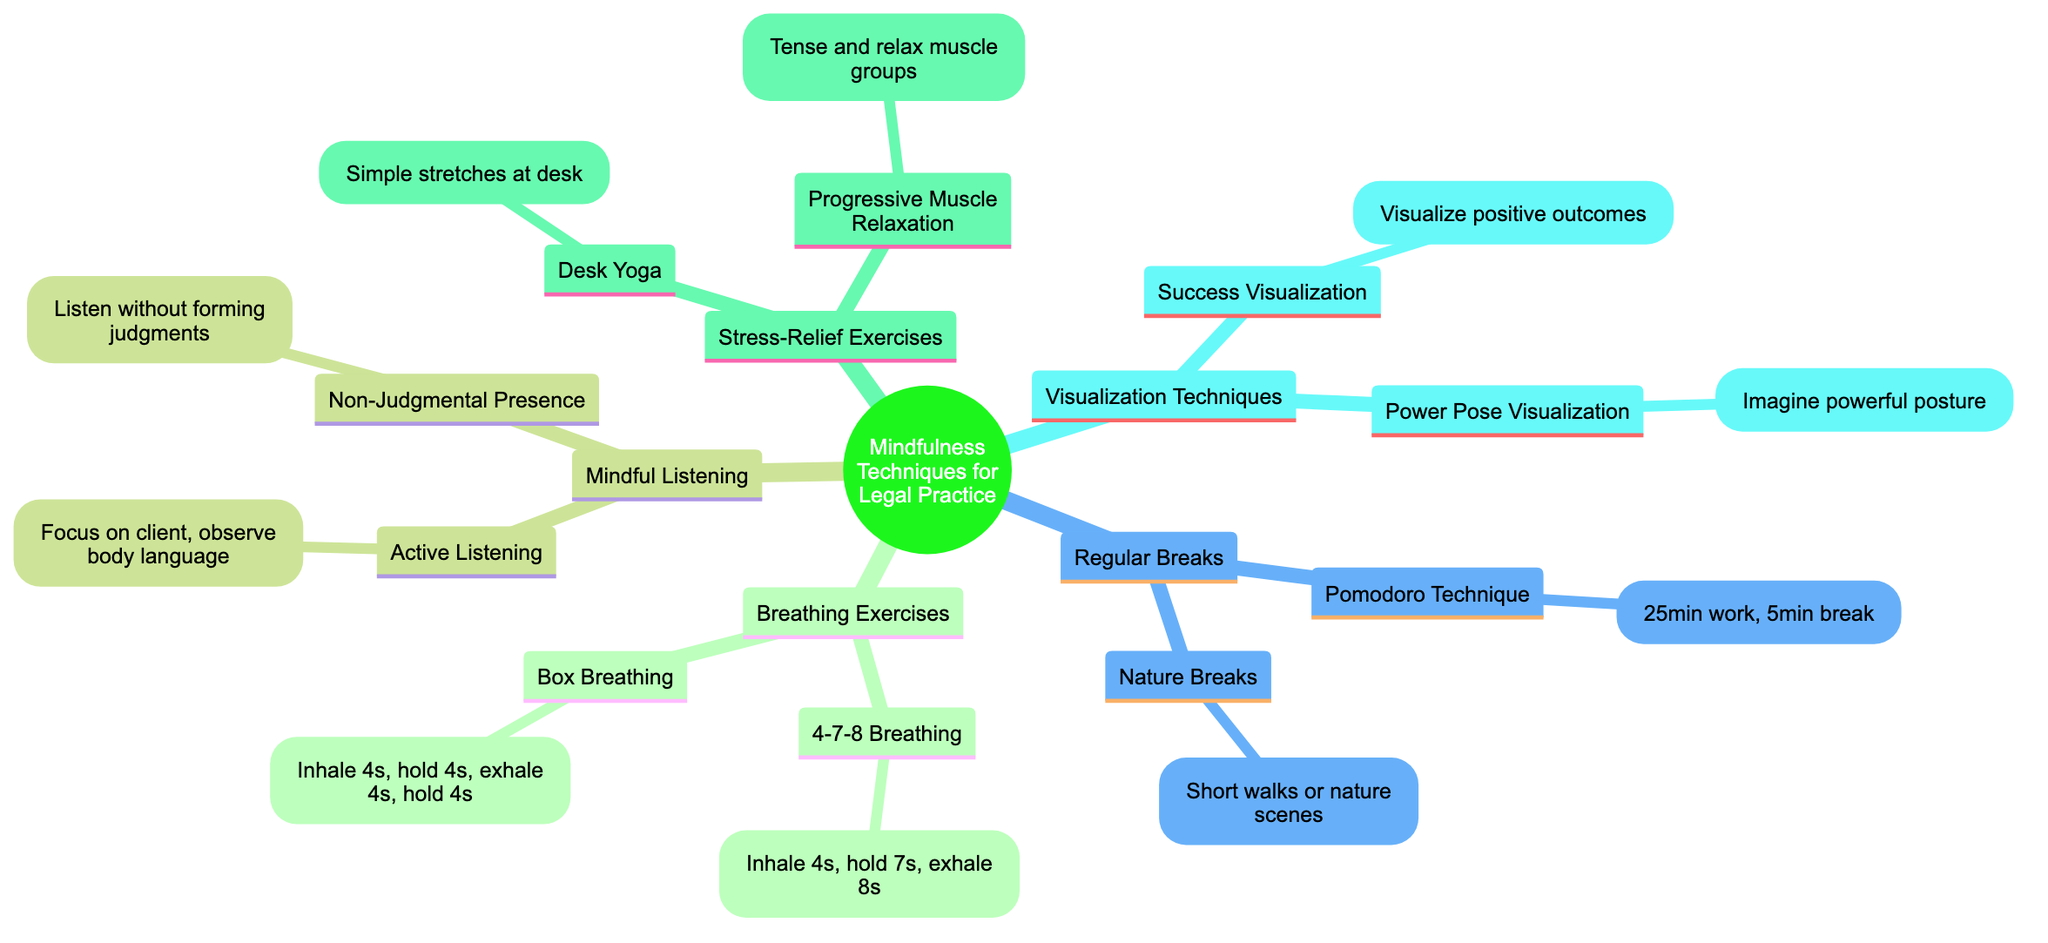What are the two breathing exercises listed? The diagram specifies two breathing exercises: 4-7-8 Breathing and Box Breathing. They are both found under the "Breathing Exercises Before Court" section.
Answer: 4-7-8 Breathing, Box Breathing How many techniques are listed under "Regular Breaks"? The "Regular Breaks" section includes two techniques: Pomodoro Technique and Nature Breaks. By counting the items listed under this section, we can determine the total.
Answer: 2 What is the visualization technique that involves imagining a powerful posture? The diagram mentions "Power Pose Visualization" as the technique related to imagining a powerful posture. This is found under "Visualization Techniques for Confidence."
Answer: Power Pose Visualization Which stress-relief exercise involves tensing and relaxing muscle groups? The diagram specifies "Progressive Muscle Relaxation" as the stress-relief exercise that involves tensing and relaxing muscle groups, found under the "Stress-Relief Exercises during Work" section.
Answer: Progressive Muscle Relaxation What is the total number of mindfulness techniques listed in the diagram? To determine the total number of techniques, we add the number of techniques from each main category. There are 2 from Breathing Exercises, 2 from Mindful Listening, 2 from Stress-Relief Exercises, 2 from Visualization Techniques, and 2 from Regular Breaks, totaling 10 techniques.
Answer: 10 What is one technique listed under "Mindful Listening in Client Meetings"? The diagram indicates that "Active Listening" is one technique listed under "Mindful Listening in Client Meetings." This technique focuses on the client and their body language.
Answer: Active Listening What does the Pomodoro Technique involve in terms of working hours? According to the diagram, the Pomodoro Technique involves working for 25 minutes followed by a 5-minute break. This can help in managing time effectively and incorporating regular breaks.
Answer: 25 minutes, 5 minutes Which technique encourages taking short walks outside? The diagram identifies "Nature Breaks" as the technique that encourages taking short walks outside or looking at nature scenes to rejuvenate the mind. This is categorized under "Regular Breaks."
Answer: Nature Breaks 